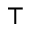<formula> <loc_0><loc_0><loc_500><loc_500>\top</formula> 